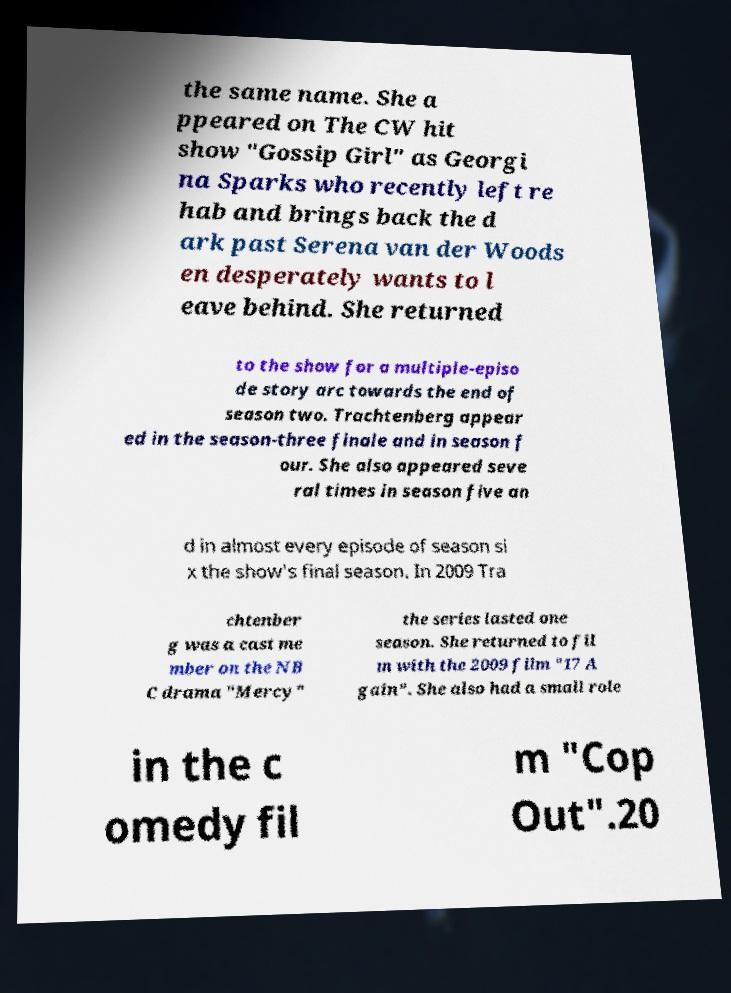I need the written content from this picture converted into text. Can you do that? the same name. She a ppeared on The CW hit show "Gossip Girl" as Georgi na Sparks who recently left re hab and brings back the d ark past Serena van der Woods en desperately wants to l eave behind. She returned to the show for a multiple-episo de story arc towards the end of season two. Trachtenberg appear ed in the season-three finale and in season f our. She also appeared seve ral times in season five an d in almost every episode of season si x the show's final season. In 2009 Tra chtenber g was a cast me mber on the NB C drama "Mercy" the series lasted one season. She returned to fil m with the 2009 film "17 A gain". She also had a small role in the c omedy fil m "Cop Out".20 